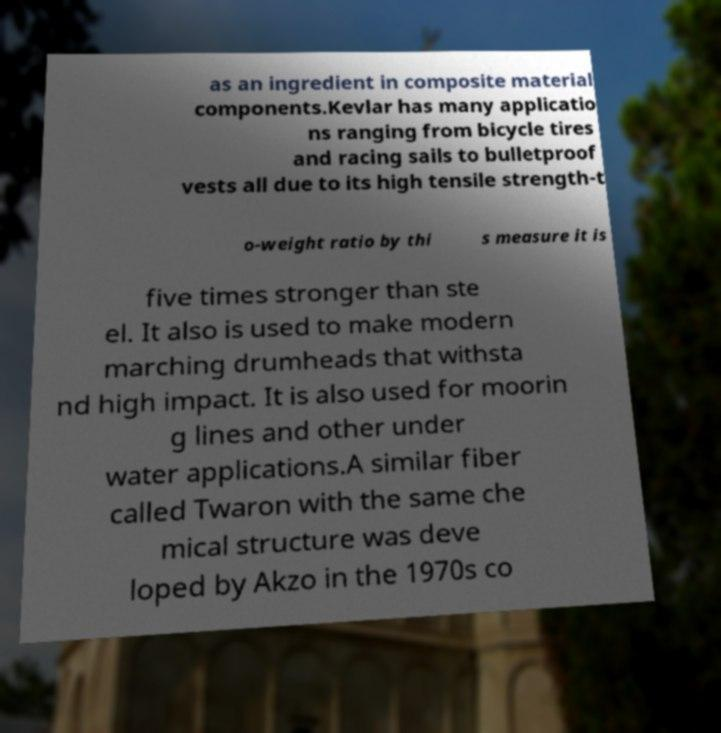Could you extract and type out the text from this image? as an ingredient in composite material components.Kevlar has many applicatio ns ranging from bicycle tires and racing sails to bulletproof vests all due to its high tensile strength-t o-weight ratio by thi s measure it is five times stronger than ste el. It also is used to make modern marching drumheads that withsta nd high impact. It is also used for moorin g lines and other under water applications.A similar fiber called Twaron with the same che mical structure was deve loped by Akzo in the 1970s co 